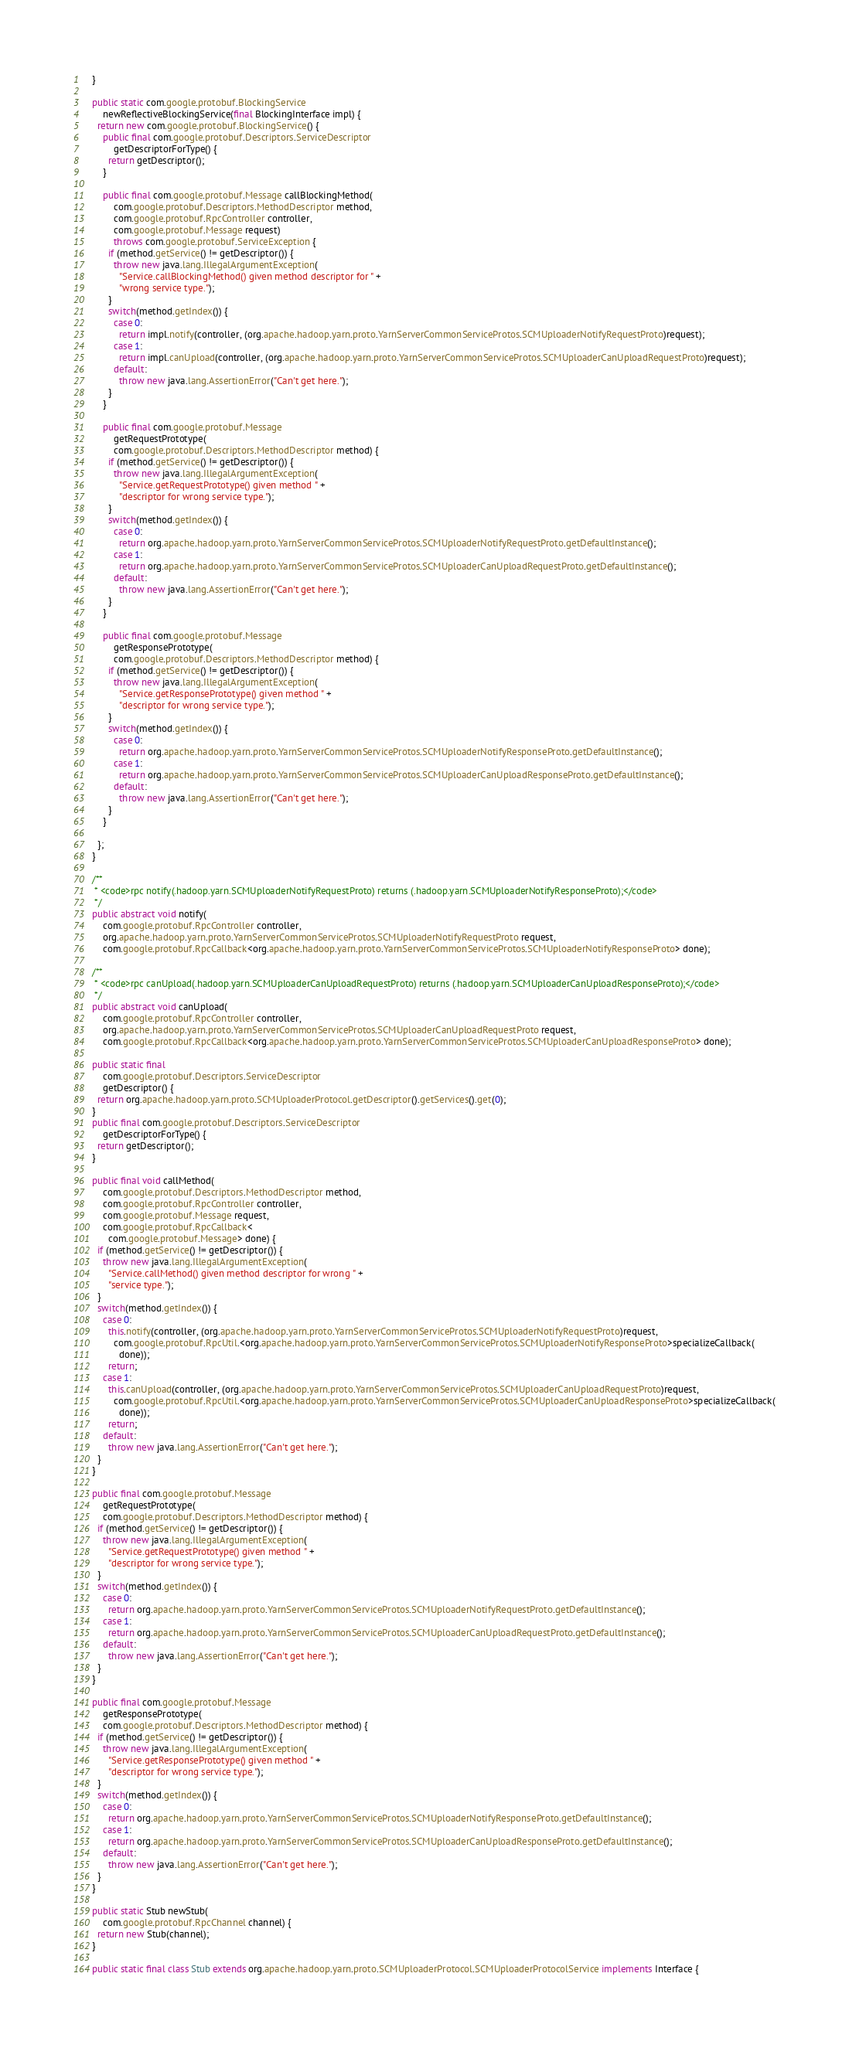<code> <loc_0><loc_0><loc_500><loc_500><_Java_>    }

    public static com.google.protobuf.BlockingService
        newReflectiveBlockingService(final BlockingInterface impl) {
      return new com.google.protobuf.BlockingService() {
        public final com.google.protobuf.Descriptors.ServiceDescriptor
            getDescriptorForType() {
          return getDescriptor();
        }

        public final com.google.protobuf.Message callBlockingMethod(
            com.google.protobuf.Descriptors.MethodDescriptor method,
            com.google.protobuf.RpcController controller,
            com.google.protobuf.Message request)
            throws com.google.protobuf.ServiceException {
          if (method.getService() != getDescriptor()) {
            throw new java.lang.IllegalArgumentException(
              "Service.callBlockingMethod() given method descriptor for " +
              "wrong service type.");
          }
          switch(method.getIndex()) {
            case 0:
              return impl.notify(controller, (org.apache.hadoop.yarn.proto.YarnServerCommonServiceProtos.SCMUploaderNotifyRequestProto)request);
            case 1:
              return impl.canUpload(controller, (org.apache.hadoop.yarn.proto.YarnServerCommonServiceProtos.SCMUploaderCanUploadRequestProto)request);
            default:
              throw new java.lang.AssertionError("Can't get here.");
          }
        }

        public final com.google.protobuf.Message
            getRequestPrototype(
            com.google.protobuf.Descriptors.MethodDescriptor method) {
          if (method.getService() != getDescriptor()) {
            throw new java.lang.IllegalArgumentException(
              "Service.getRequestPrototype() given method " +
              "descriptor for wrong service type.");
          }
          switch(method.getIndex()) {
            case 0:
              return org.apache.hadoop.yarn.proto.YarnServerCommonServiceProtos.SCMUploaderNotifyRequestProto.getDefaultInstance();
            case 1:
              return org.apache.hadoop.yarn.proto.YarnServerCommonServiceProtos.SCMUploaderCanUploadRequestProto.getDefaultInstance();
            default:
              throw new java.lang.AssertionError("Can't get here.");
          }
        }

        public final com.google.protobuf.Message
            getResponsePrototype(
            com.google.protobuf.Descriptors.MethodDescriptor method) {
          if (method.getService() != getDescriptor()) {
            throw new java.lang.IllegalArgumentException(
              "Service.getResponsePrototype() given method " +
              "descriptor for wrong service type.");
          }
          switch(method.getIndex()) {
            case 0:
              return org.apache.hadoop.yarn.proto.YarnServerCommonServiceProtos.SCMUploaderNotifyResponseProto.getDefaultInstance();
            case 1:
              return org.apache.hadoop.yarn.proto.YarnServerCommonServiceProtos.SCMUploaderCanUploadResponseProto.getDefaultInstance();
            default:
              throw new java.lang.AssertionError("Can't get here.");
          }
        }

      };
    }

    /**
     * <code>rpc notify(.hadoop.yarn.SCMUploaderNotifyRequestProto) returns (.hadoop.yarn.SCMUploaderNotifyResponseProto);</code>
     */
    public abstract void notify(
        com.google.protobuf.RpcController controller,
        org.apache.hadoop.yarn.proto.YarnServerCommonServiceProtos.SCMUploaderNotifyRequestProto request,
        com.google.protobuf.RpcCallback<org.apache.hadoop.yarn.proto.YarnServerCommonServiceProtos.SCMUploaderNotifyResponseProto> done);

    /**
     * <code>rpc canUpload(.hadoop.yarn.SCMUploaderCanUploadRequestProto) returns (.hadoop.yarn.SCMUploaderCanUploadResponseProto);</code>
     */
    public abstract void canUpload(
        com.google.protobuf.RpcController controller,
        org.apache.hadoop.yarn.proto.YarnServerCommonServiceProtos.SCMUploaderCanUploadRequestProto request,
        com.google.protobuf.RpcCallback<org.apache.hadoop.yarn.proto.YarnServerCommonServiceProtos.SCMUploaderCanUploadResponseProto> done);

    public static final
        com.google.protobuf.Descriptors.ServiceDescriptor
        getDescriptor() {
      return org.apache.hadoop.yarn.proto.SCMUploaderProtocol.getDescriptor().getServices().get(0);
    }
    public final com.google.protobuf.Descriptors.ServiceDescriptor
        getDescriptorForType() {
      return getDescriptor();
    }

    public final void callMethod(
        com.google.protobuf.Descriptors.MethodDescriptor method,
        com.google.protobuf.RpcController controller,
        com.google.protobuf.Message request,
        com.google.protobuf.RpcCallback<
          com.google.protobuf.Message> done) {
      if (method.getService() != getDescriptor()) {
        throw new java.lang.IllegalArgumentException(
          "Service.callMethod() given method descriptor for wrong " +
          "service type.");
      }
      switch(method.getIndex()) {
        case 0:
          this.notify(controller, (org.apache.hadoop.yarn.proto.YarnServerCommonServiceProtos.SCMUploaderNotifyRequestProto)request,
            com.google.protobuf.RpcUtil.<org.apache.hadoop.yarn.proto.YarnServerCommonServiceProtos.SCMUploaderNotifyResponseProto>specializeCallback(
              done));
          return;
        case 1:
          this.canUpload(controller, (org.apache.hadoop.yarn.proto.YarnServerCommonServiceProtos.SCMUploaderCanUploadRequestProto)request,
            com.google.protobuf.RpcUtil.<org.apache.hadoop.yarn.proto.YarnServerCommonServiceProtos.SCMUploaderCanUploadResponseProto>specializeCallback(
              done));
          return;
        default:
          throw new java.lang.AssertionError("Can't get here.");
      }
    }

    public final com.google.protobuf.Message
        getRequestPrototype(
        com.google.protobuf.Descriptors.MethodDescriptor method) {
      if (method.getService() != getDescriptor()) {
        throw new java.lang.IllegalArgumentException(
          "Service.getRequestPrototype() given method " +
          "descriptor for wrong service type.");
      }
      switch(method.getIndex()) {
        case 0:
          return org.apache.hadoop.yarn.proto.YarnServerCommonServiceProtos.SCMUploaderNotifyRequestProto.getDefaultInstance();
        case 1:
          return org.apache.hadoop.yarn.proto.YarnServerCommonServiceProtos.SCMUploaderCanUploadRequestProto.getDefaultInstance();
        default:
          throw new java.lang.AssertionError("Can't get here.");
      }
    }

    public final com.google.protobuf.Message
        getResponsePrototype(
        com.google.protobuf.Descriptors.MethodDescriptor method) {
      if (method.getService() != getDescriptor()) {
        throw new java.lang.IllegalArgumentException(
          "Service.getResponsePrototype() given method " +
          "descriptor for wrong service type.");
      }
      switch(method.getIndex()) {
        case 0:
          return org.apache.hadoop.yarn.proto.YarnServerCommonServiceProtos.SCMUploaderNotifyResponseProto.getDefaultInstance();
        case 1:
          return org.apache.hadoop.yarn.proto.YarnServerCommonServiceProtos.SCMUploaderCanUploadResponseProto.getDefaultInstance();
        default:
          throw new java.lang.AssertionError("Can't get here.");
      }
    }

    public static Stub newStub(
        com.google.protobuf.RpcChannel channel) {
      return new Stub(channel);
    }

    public static final class Stub extends org.apache.hadoop.yarn.proto.SCMUploaderProtocol.SCMUploaderProtocolService implements Interface {</code> 